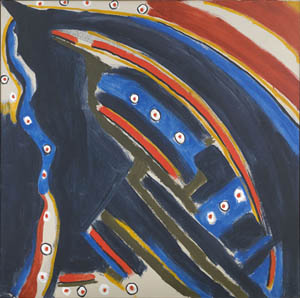Can you invent a wild, fantastical question about this image? What if this image is a portal map to an alternate universe where the laws of physics are governed by the colors and patterns seen here? How would explorers navigate this new universe using this map, and what kinds of phenomena might they encounter? What could be a short realistic scenario portrayed by this image? This image might realistically portray the abstract pattern of sea currents at night, captured using a long-exposure photograph. The dots could represent bioluminescent organisms dispersed across the ocean waves. Can you write a long realistic scenario inspired by this image? Imagine a deep sea exploration vessel equipped with advanced sonar and imaging technology. This painting reflects the complex topography of an undiscovered underwater trench captured by the vessel's scanners. The vast and dark sections indicate the depths, while the vivid dots and lines map out the bioelectric signals emitted by deep-sea creatures. The patterns reveal a hidden ecosystem teeming with unknown species and intricate coral formations. This scan becomes a crucial artifact for marine biologists and oceanographers, offering groundbreaking insights into the uncharted territories beneath the ocean's surface. As researchers analyze the data, they discover clues about the evolutionary adaptations of these creatures to their high-pressure, low-light environment. The abstract, yet data-rich image, leads to numerous scientific breakthroughs, opening up possibilities for sustainable resource harvesting, new medicinal compounds, and a deeper understanding of Earth's final frontier. 